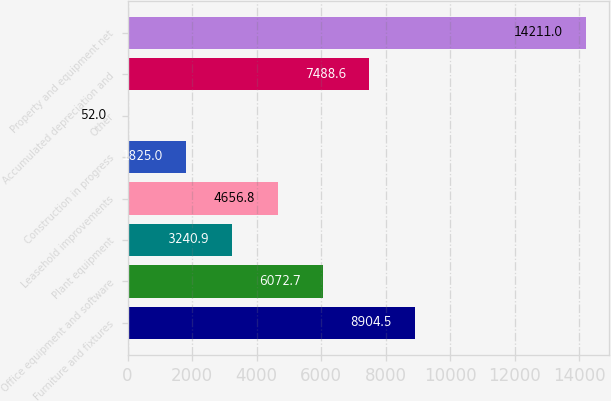Convert chart to OTSL. <chart><loc_0><loc_0><loc_500><loc_500><bar_chart><fcel>Furniture and fixtures<fcel>Office equipment and software<fcel>Plant equipment<fcel>Leasehold improvements<fcel>Construction in progress<fcel>Other<fcel>Accumulated depreciation and<fcel>Property and equipment net<nl><fcel>8904.5<fcel>6072.7<fcel>3240.9<fcel>4656.8<fcel>1825<fcel>52<fcel>7488.6<fcel>14211<nl></chart> 